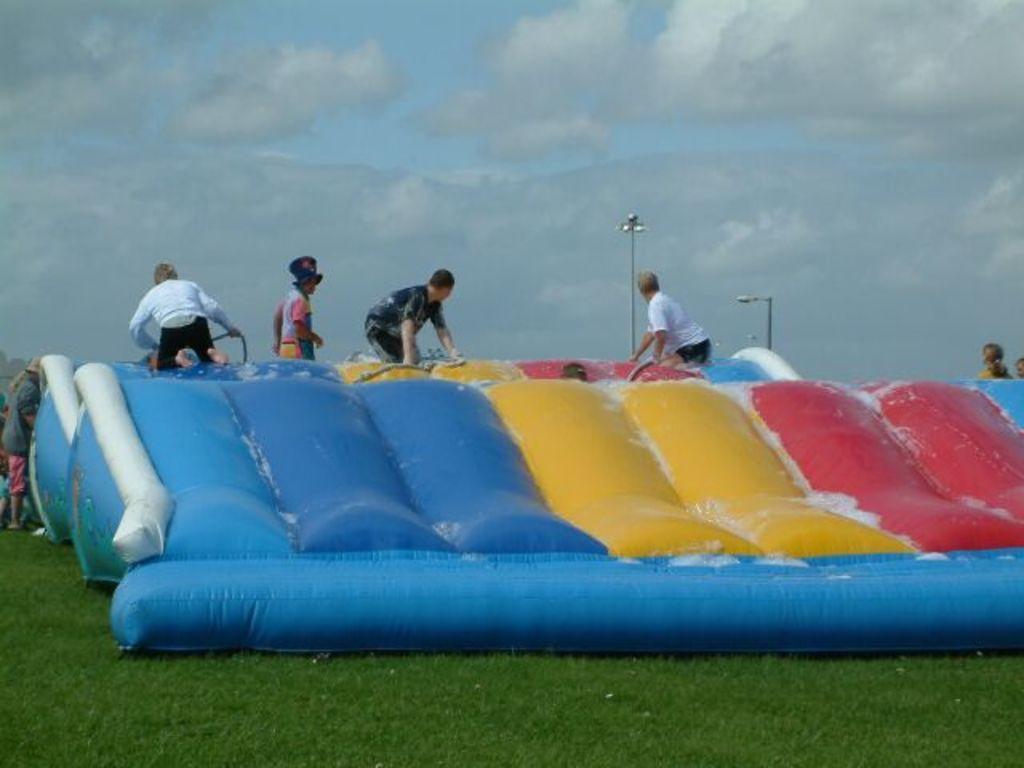In one or two sentences, can you explain what this image depicts? In the image we can see an inflatable, on it there are people wearing clothes, this is a light pole, grass and a cloudy sky. 